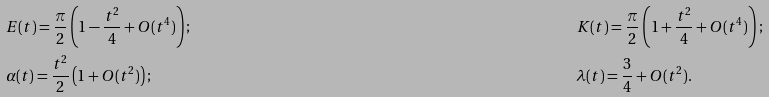<formula> <loc_0><loc_0><loc_500><loc_500>& E ( t ) = \frac { \pi } { 2 } \left ( 1 - \frac { t ^ { 2 } } { 4 } + O ( t ^ { 4 } ) \right ) ; & & K ( t ) = \frac { \pi } { 2 } \left ( 1 + \frac { t ^ { 2 } } { 4 } + O ( t ^ { 4 } ) \right ) ; \\ & \alpha ( t ) = \frac { t ^ { 2 } } { 2 } \left ( 1 + O ( t ^ { 2 } ) \right ) ; & & \lambda ( t ) = \frac { 3 } { 4 } + O ( t ^ { 2 } ) .</formula> 